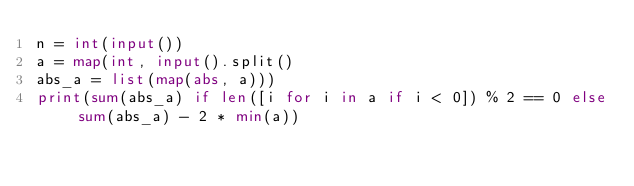Convert code to text. <code><loc_0><loc_0><loc_500><loc_500><_Python_>n = int(input())
a = map(int, input().split()
abs_a = list(map(abs, a)))
print(sum(abs_a) if len([i for i in a if i < 0]) % 2 == 0 else sum(abs_a) - 2 * min(a))
</code> 